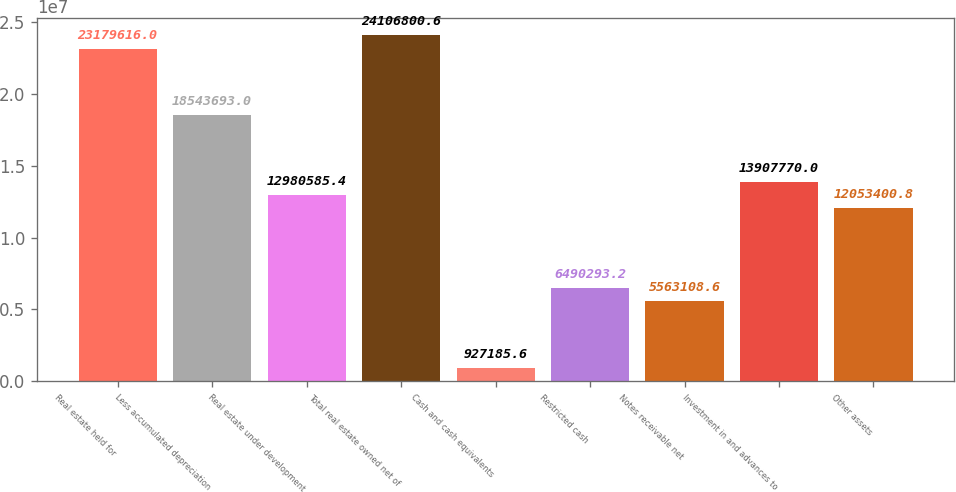<chart> <loc_0><loc_0><loc_500><loc_500><bar_chart><fcel>Real estate held for<fcel>Less accumulated depreciation<fcel>Real estate under development<fcel>Total real estate owned net of<fcel>Cash and cash equivalents<fcel>Restricted cash<fcel>Notes receivable net<fcel>Investment in and advances to<fcel>Other assets<nl><fcel>2.31796e+07<fcel>1.85437e+07<fcel>1.29806e+07<fcel>2.41068e+07<fcel>927186<fcel>6.49029e+06<fcel>5.56311e+06<fcel>1.39078e+07<fcel>1.20534e+07<nl></chart> 